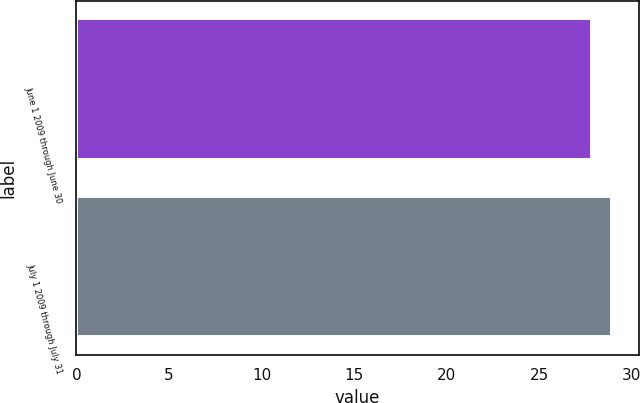Convert chart to OTSL. <chart><loc_0><loc_0><loc_500><loc_500><bar_chart><fcel>June 1 2009 through June 30<fcel>July 1 2009 through July 31<nl><fcel>27.86<fcel>28.92<nl></chart> 